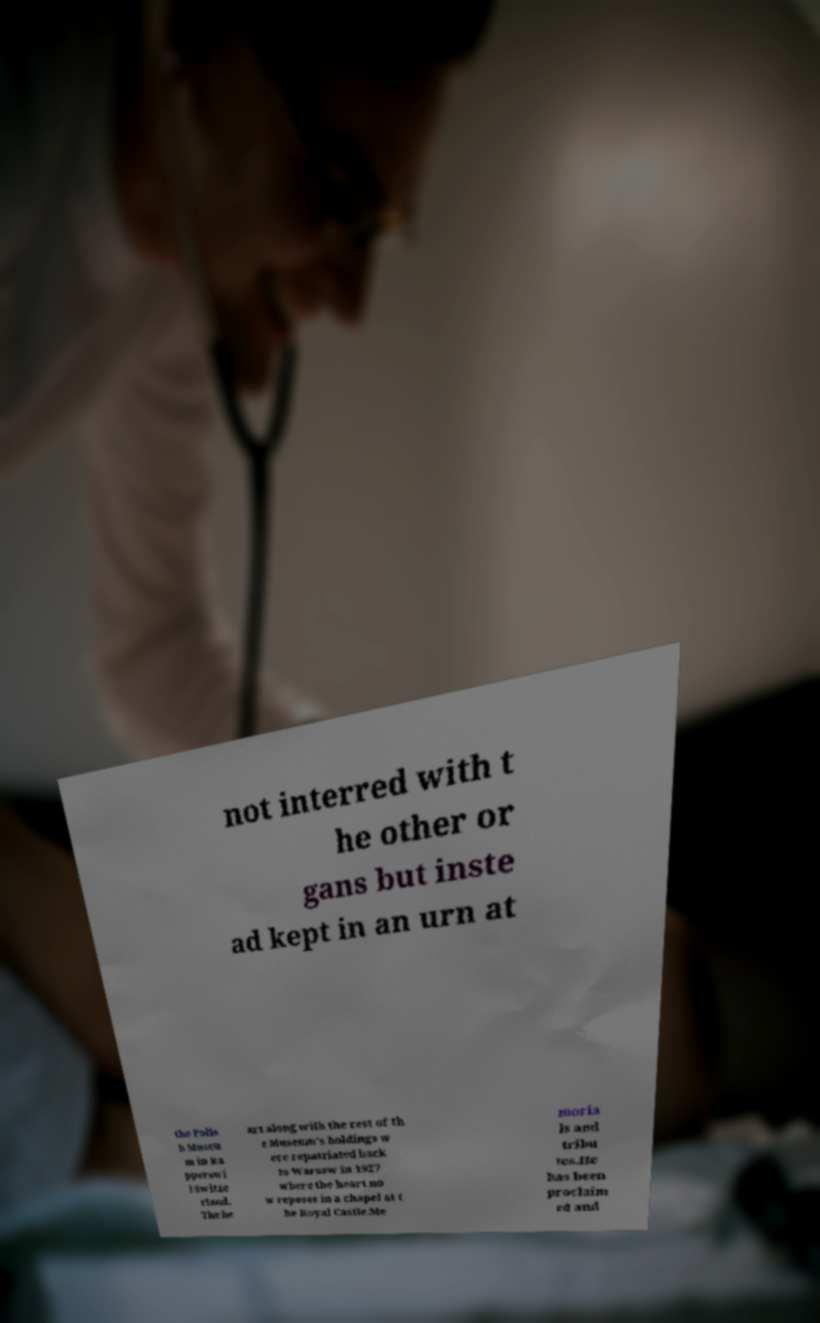Can you read and provide the text displayed in the image?This photo seems to have some interesting text. Can you extract and type it out for me? not interred with t he other or gans but inste ad kept in an urn at the Polis h Museu m in Ra pperswi l Switze rland. The he art along with the rest of th e Museum's holdings w ere repatriated back to Warsaw in 1927 where the heart no w reposes in a chapel at t he Royal Castle.Me moria ls and tribu tes.He has been proclaim ed and 